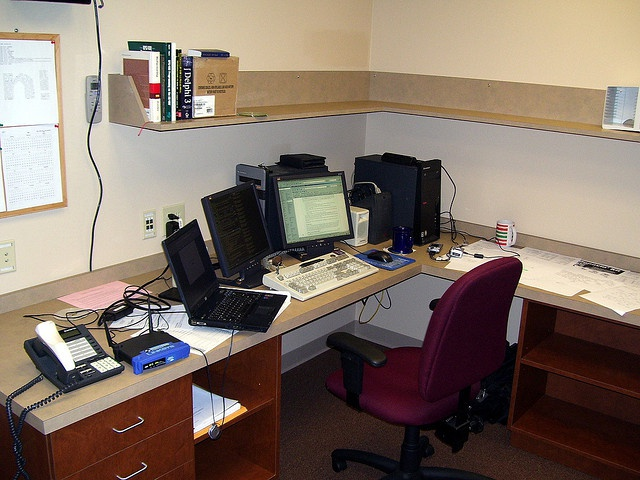Describe the objects in this image and their specific colors. I can see chair in darkgray, black, purple, and gray tones, laptop in darkgray, black, gray, and white tones, keyboard in darkgray, beige, and gray tones, book in darkgray, tan, gray, white, and olive tones, and book in darkgray, ivory, and brown tones in this image. 